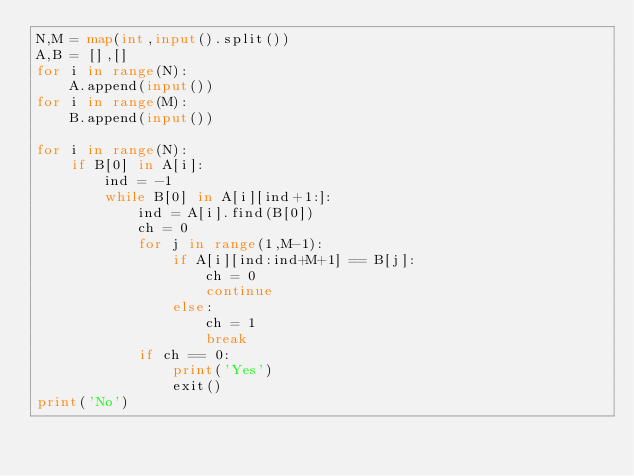Convert code to text. <code><loc_0><loc_0><loc_500><loc_500><_Python_>N,M = map(int,input().split())
A,B = [],[]
for i in range(N):
    A.append(input())
for i in range(M):
    B.append(input())

for i in range(N):
    if B[0] in A[i]:
        ind = -1
        while B[0] in A[i][ind+1:]:
            ind = A[i].find(B[0])
            ch = 0
            for j in range(1,M-1):
                if A[i][ind:ind+M+1] == B[j]:
                    ch = 0
                    continue
                else:
                    ch = 1
                    break
            if ch == 0:
                print('Yes')
                exit()
print('No')
</code> 